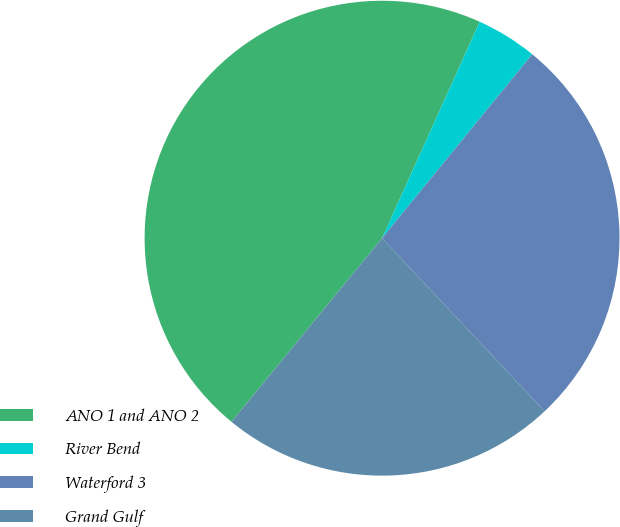Convert chart to OTSL. <chart><loc_0><loc_0><loc_500><loc_500><pie_chart><fcel>ANO 1 and ANO 2<fcel>River Bend<fcel>Waterford 3<fcel>Grand Gulf<nl><fcel>45.82%<fcel>4.15%<fcel>27.1%<fcel>22.93%<nl></chart> 